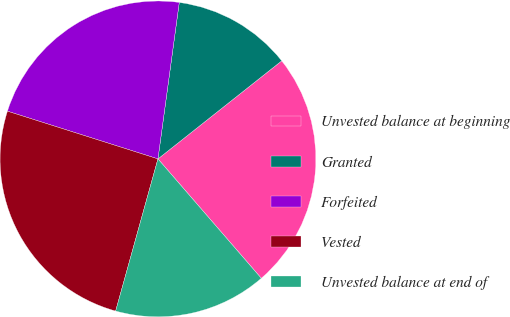<chart> <loc_0><loc_0><loc_500><loc_500><pie_chart><fcel>Unvested balance at beginning<fcel>Granted<fcel>Forfeited<fcel>Vested<fcel>Unvested balance at end of<nl><fcel>24.31%<fcel>12.18%<fcel>22.27%<fcel>25.57%<fcel>15.67%<nl></chart> 